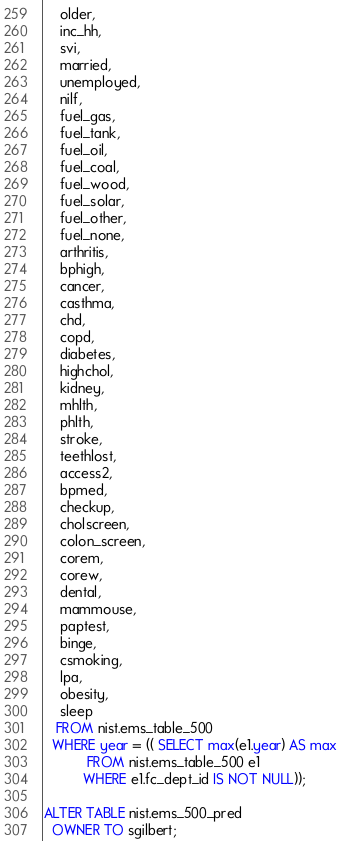Convert code to text. <code><loc_0><loc_0><loc_500><loc_500><_SQL_>    older,
    inc_hh,
    svi,
    married,
    unemployed,
    nilf,
    fuel_gas,
    fuel_tank,
    fuel_oil,
    fuel_coal,
    fuel_wood,
    fuel_solar,
    fuel_other,
    fuel_none,
    arthritis,
    bphigh,
    cancer,
    casthma,
    chd,
    copd,
    diabetes,
    highchol,
    kidney,
    mhlth,
    phlth,
    stroke,
    teethlost,
    access2,
    bpmed,
    checkup,
    cholscreen,
    colon_screen,
    corem,
    corew,
    dental,
    mammouse,
    paptest,
    binge,
    csmoking,
    lpa,
    obesity,
    sleep
   FROM nist.ems_table_500
  WHERE year = (( SELECT max(e1.year) AS max
           FROM nist.ems_table_500 e1
          WHERE e1.fc_dept_id IS NOT NULL));

ALTER TABLE nist.ems_500_pred
  OWNER TO sgilbert;
</code> 